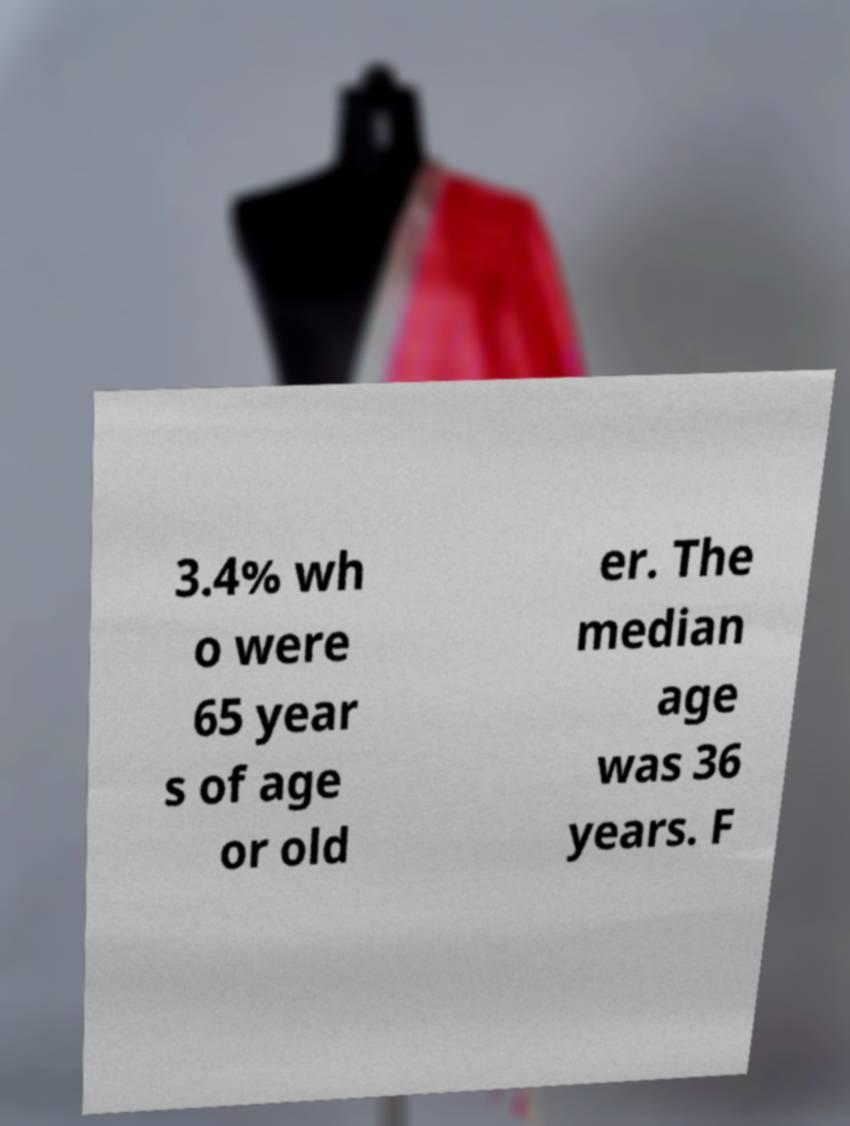Could you assist in decoding the text presented in this image and type it out clearly? 3.4% wh o were 65 year s of age or old er. The median age was 36 years. F 